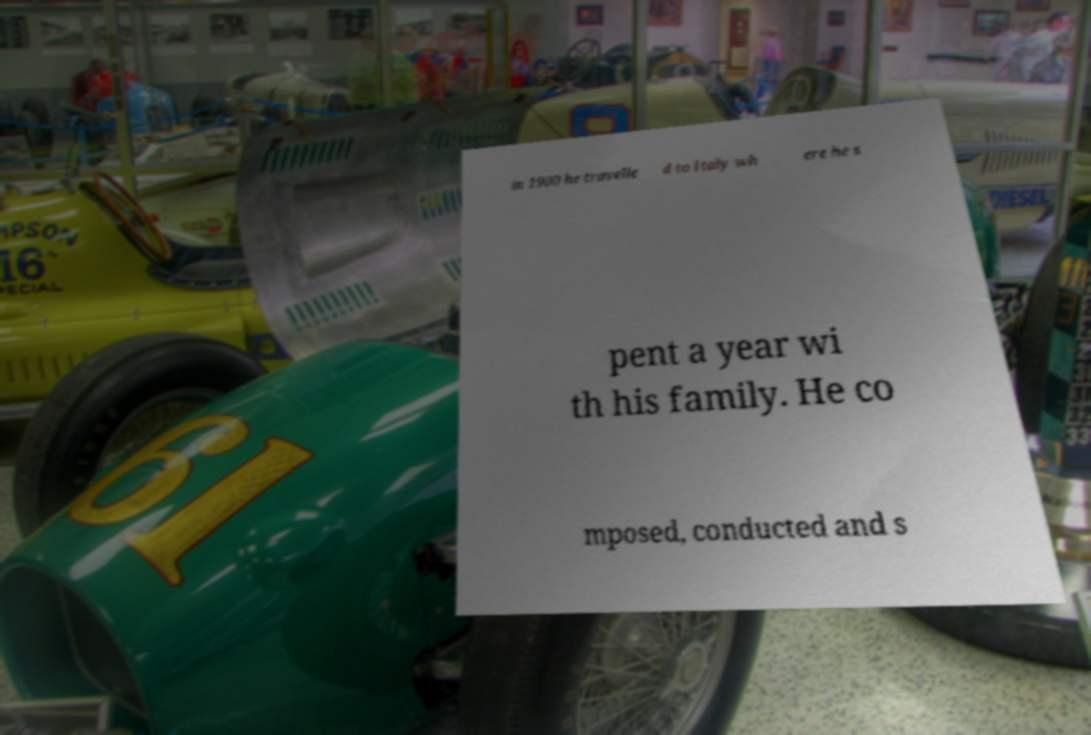Could you assist in decoding the text presented in this image and type it out clearly? in 1900 he travelle d to Italy wh ere he s pent a year wi th his family. He co mposed, conducted and s 